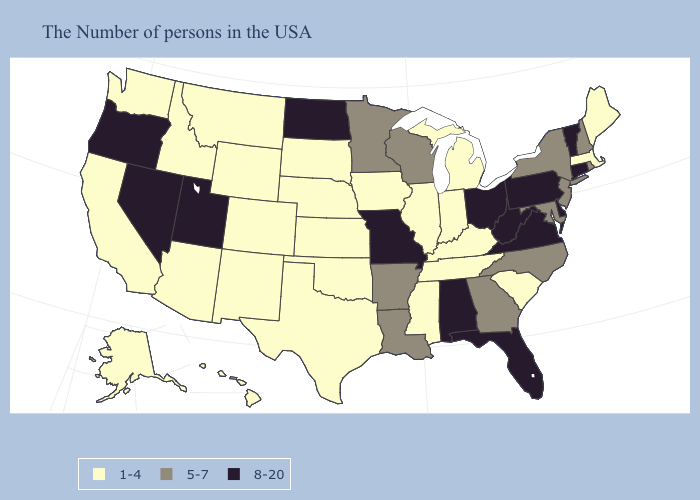Does the map have missing data?
Keep it brief. No. What is the value of Oklahoma?
Quick response, please. 1-4. What is the lowest value in states that border Utah?
Be succinct. 1-4. What is the lowest value in states that border South Carolina?
Short answer required. 5-7. Does Louisiana have the same value as Wisconsin?
Keep it brief. Yes. What is the value of Wyoming?
Keep it brief. 1-4. What is the value of Maryland?
Keep it brief. 5-7. Is the legend a continuous bar?
Write a very short answer. No. Among the states that border Nevada , which have the lowest value?
Answer briefly. Arizona, Idaho, California. Name the states that have a value in the range 8-20?
Be succinct. Vermont, Connecticut, Delaware, Pennsylvania, Virginia, West Virginia, Ohio, Florida, Alabama, Missouri, North Dakota, Utah, Nevada, Oregon. Does Illinois have the highest value in the MidWest?
Short answer required. No. What is the value of Oklahoma?
Be succinct. 1-4. Among the states that border Washington , which have the highest value?
Keep it brief. Oregon. What is the highest value in the MidWest ?
Short answer required. 8-20. What is the lowest value in the Northeast?
Short answer required. 1-4. 